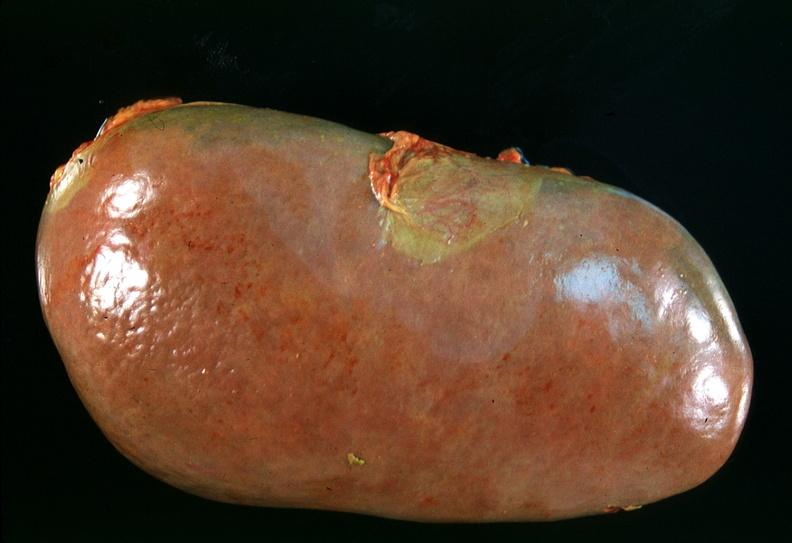does this image show spleen, chronic congestion due to portal hypertension from cirrhosis, hcv?
Answer the question using a single word or phrase. Yes 